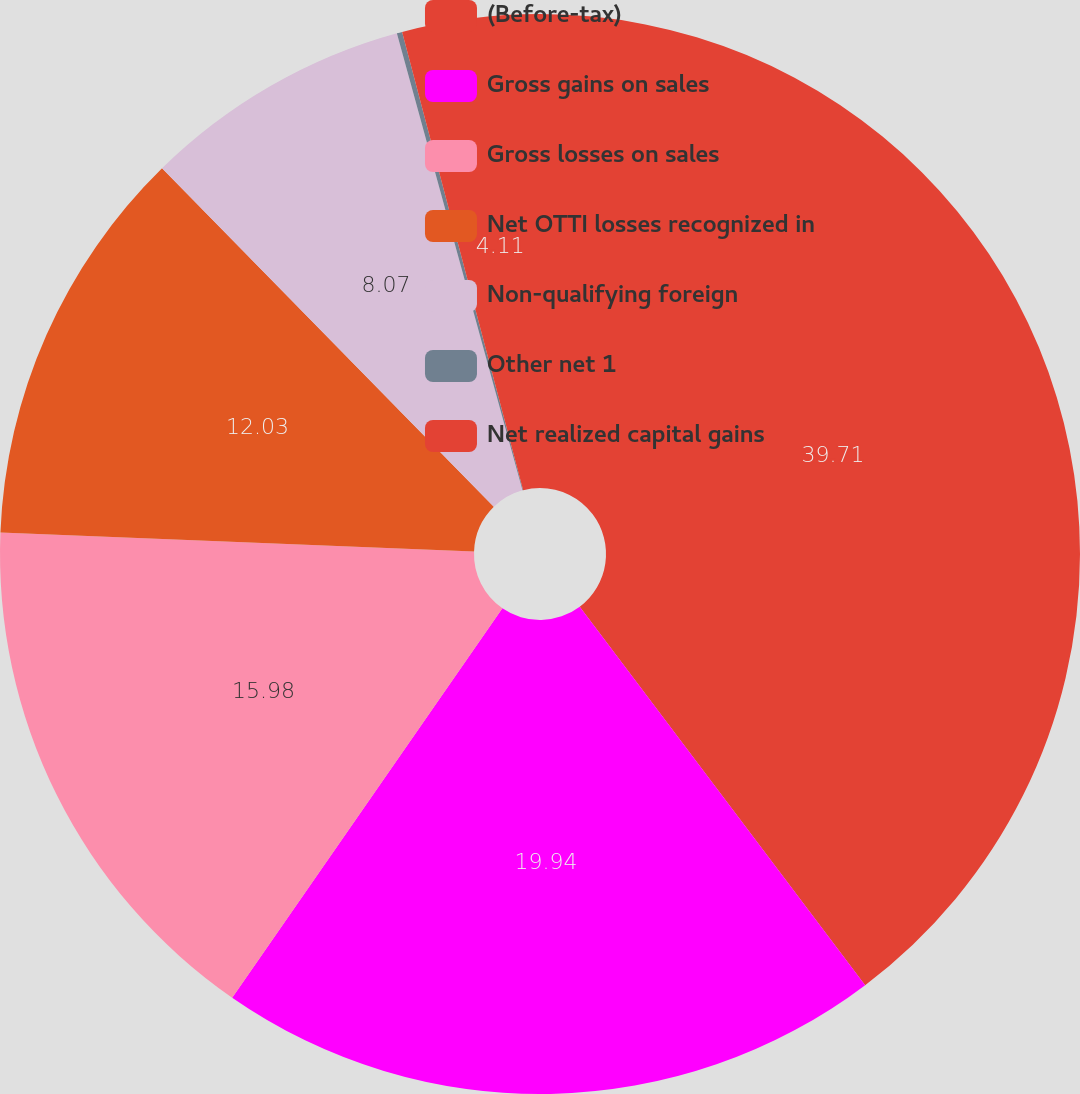Convert chart. <chart><loc_0><loc_0><loc_500><loc_500><pie_chart><fcel>(Before-tax)<fcel>Gross gains on sales<fcel>Gross losses on sales<fcel>Net OTTI losses recognized in<fcel>Non-qualifying foreign<fcel>Other net 1<fcel>Net realized capital gains<nl><fcel>39.72%<fcel>19.94%<fcel>15.98%<fcel>12.03%<fcel>8.07%<fcel>0.16%<fcel>4.11%<nl></chart> 